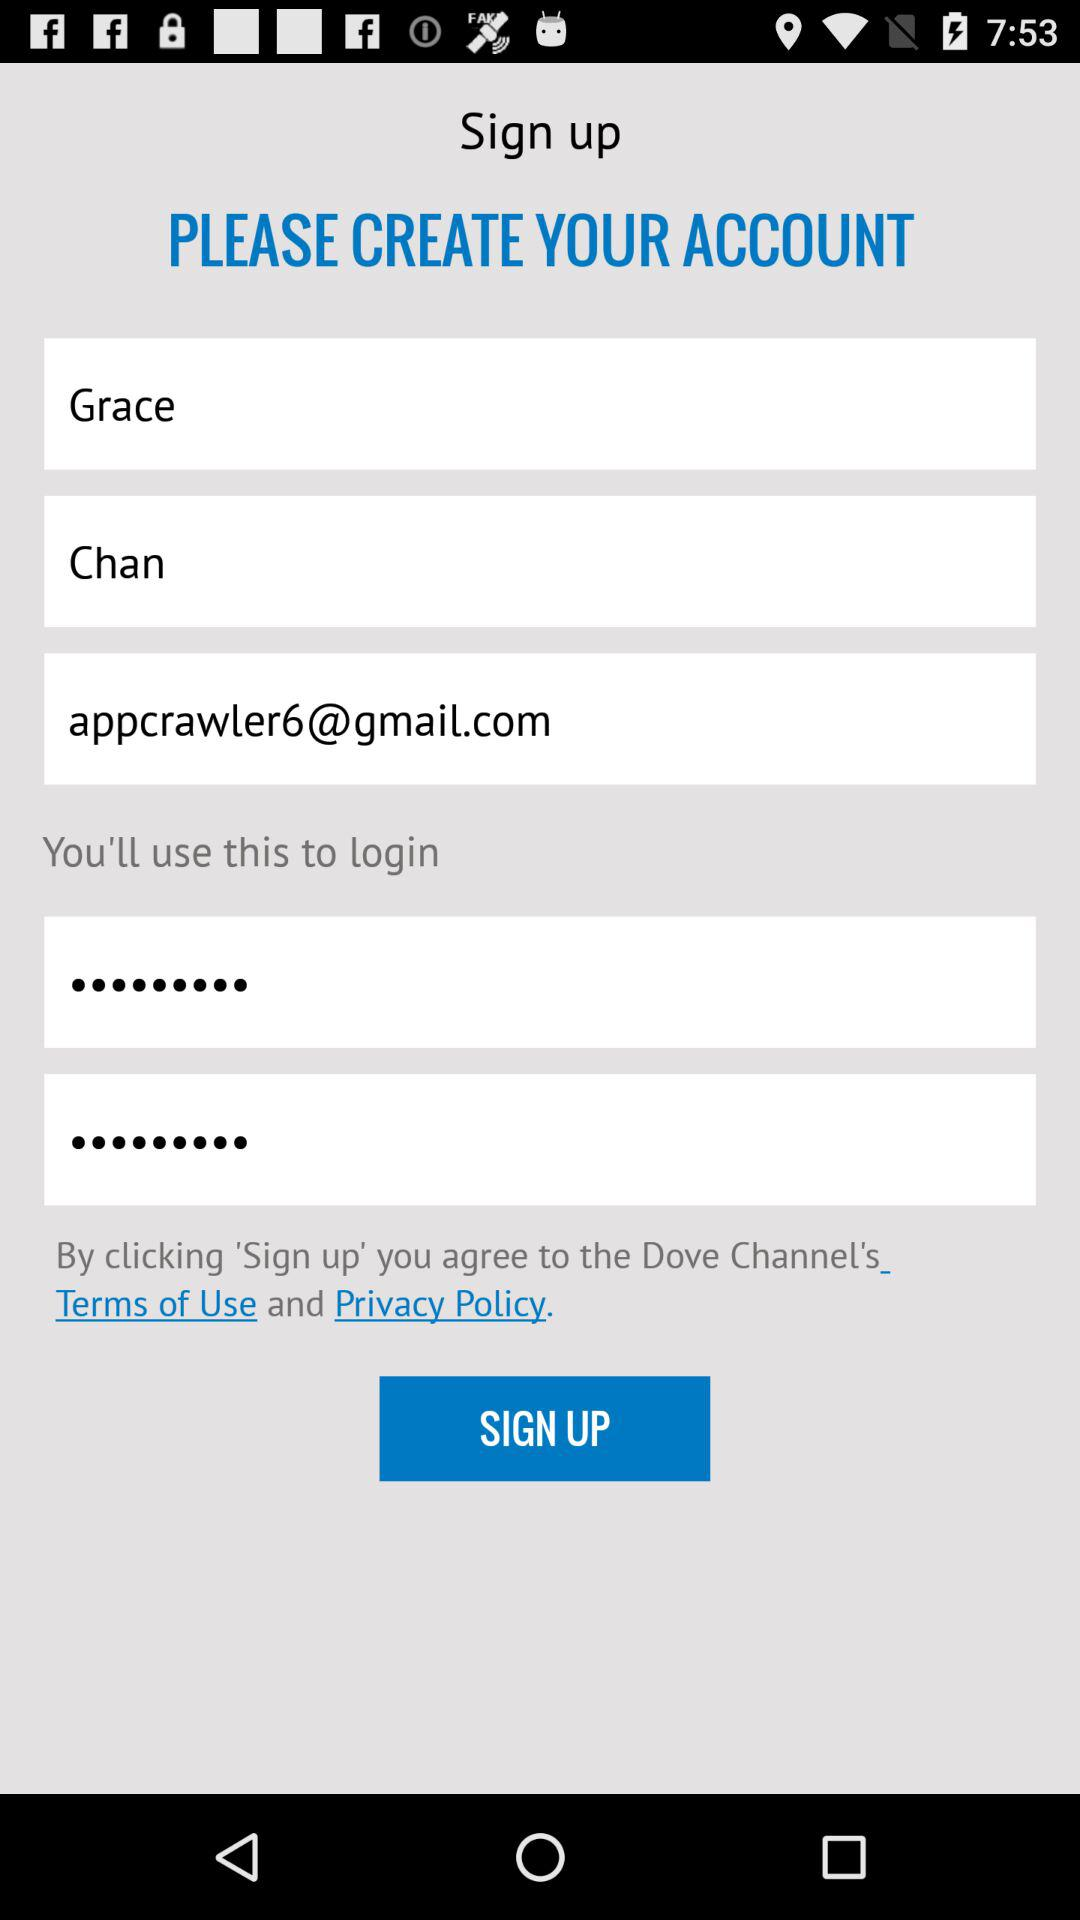What is the user name? The user name is Grace Chan. 